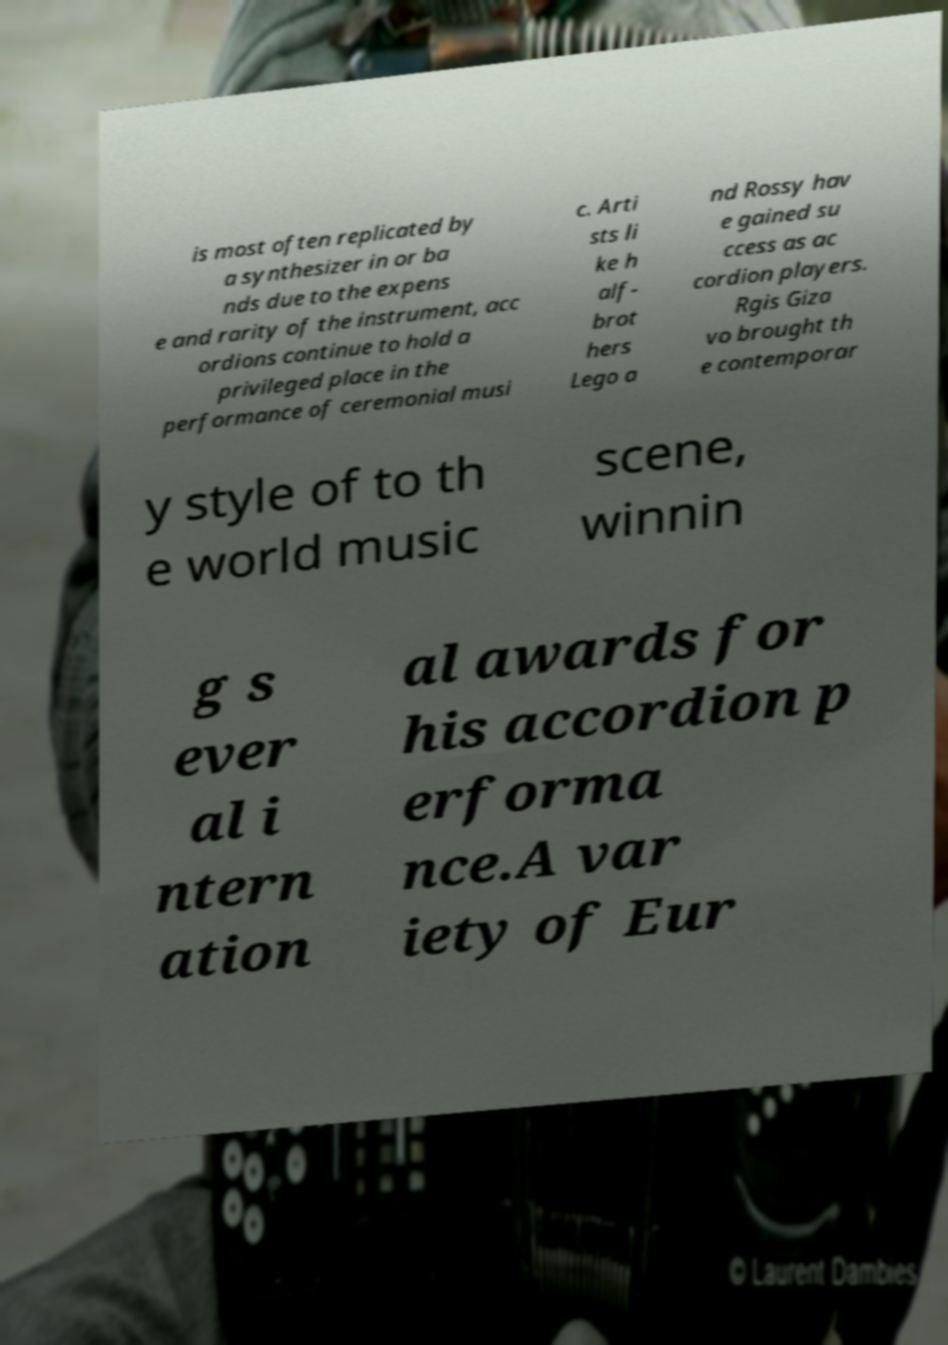There's text embedded in this image that I need extracted. Can you transcribe it verbatim? is most often replicated by a synthesizer in or ba nds due to the expens e and rarity of the instrument, acc ordions continue to hold a privileged place in the performance of ceremonial musi c. Arti sts li ke h alf- brot hers Lego a nd Rossy hav e gained su ccess as ac cordion players. Rgis Giza vo brought th e contemporar y style of to th e world music scene, winnin g s ever al i ntern ation al awards for his accordion p erforma nce.A var iety of Eur 